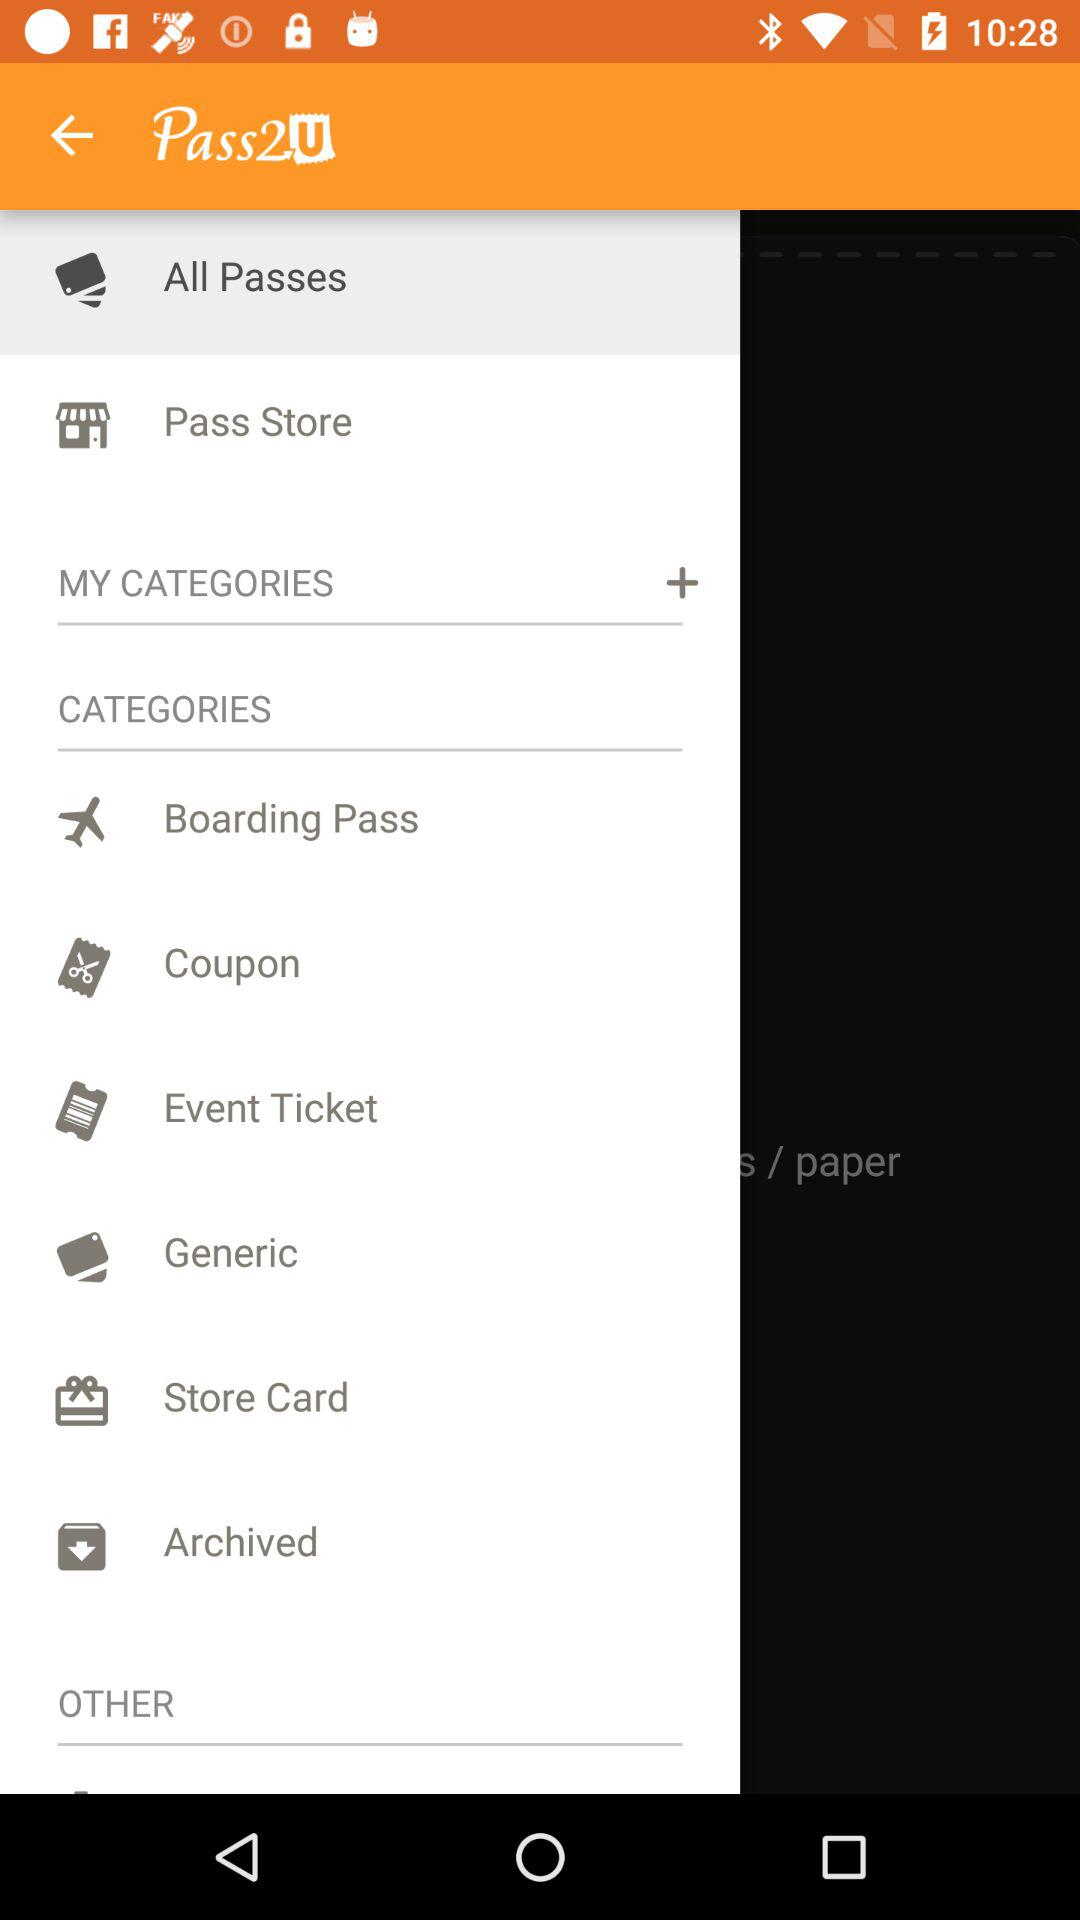What is the application name? The application name is Pass2U. 